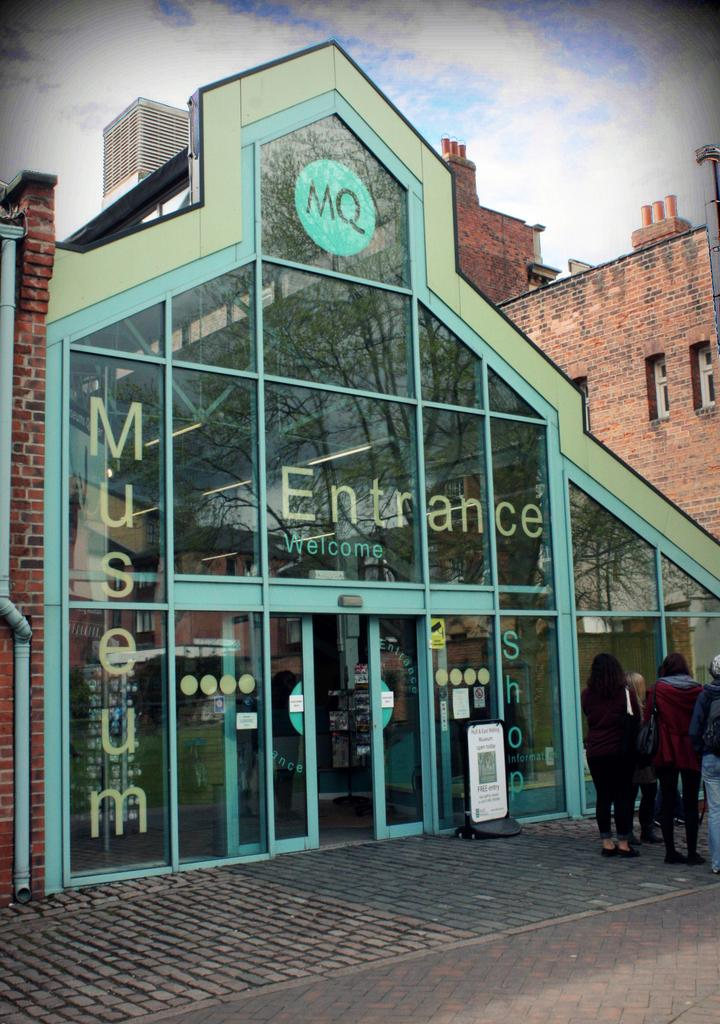What type of establishment is depicted in the image? There is a museum in the image. What can be seen around the museum? There are people standing outside the museum. What else is visible in the background of the image? There are buildings visible in the background of the image. What type of fork can be seen in the image? There is no fork present in the image. How many locks are visible on the museum in the image? There is no mention of locks on the museum in the image, so it cannot be determined. 